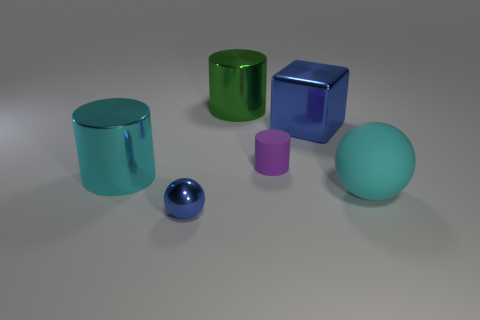Add 2 blue spheres. How many objects exist? 8 Subtract all cyan cylinders. How many cylinders are left? 2 Subtract all cyan cylinders. How many cylinders are left? 2 Subtract all cubes. How many objects are left? 5 Add 2 blue metallic cubes. How many blue metallic cubes exist? 3 Subtract 0 yellow cylinders. How many objects are left? 6 Subtract 1 cubes. How many cubes are left? 0 Subtract all blue balls. Subtract all yellow blocks. How many balls are left? 1 Subtract all gray cylinders. How many red balls are left? 0 Subtract all large green objects. Subtract all metal objects. How many objects are left? 1 